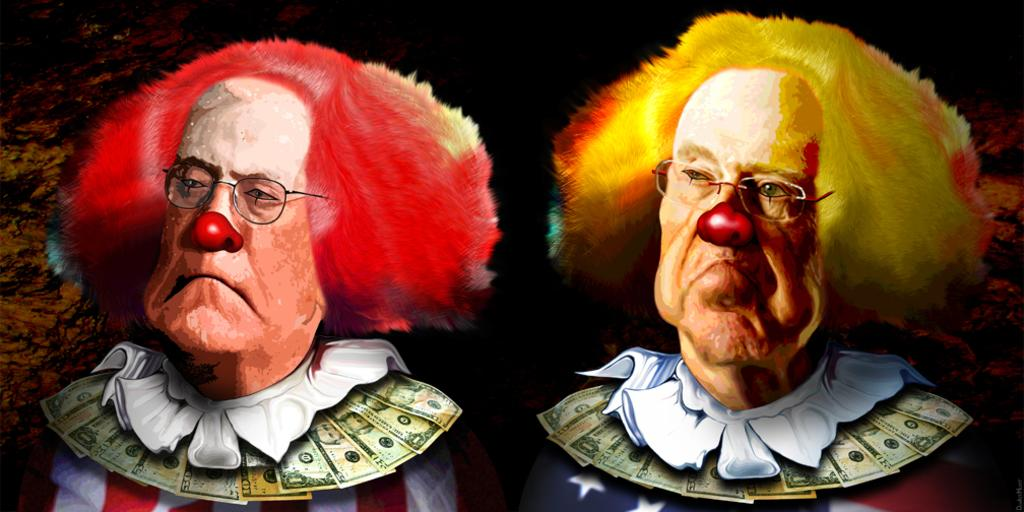How many persons are in the image? There are two persons in the image. What are the persons dressed as? Both persons are dressed as clowns. Can you describe the hair color of the person on the left? The person on the left has red hair. What is the hair color of the person on the right? The person on the right has yellow hair. What is the color of the background in the image? The background of the image is dark. What type of butter can be seen melting on the rod in the image? There is no butter or rod present in the image; it features two clowns with red and yellow hair. 